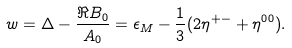Convert formula to latex. <formula><loc_0><loc_0><loc_500><loc_500>w = \Delta - \frac { \Re B _ { 0 } } { A _ { 0 } } = \epsilon _ { M } - \frac { 1 } { 3 } ( 2 \eta ^ { + - } + \eta ^ { 0 0 } ) .</formula> 